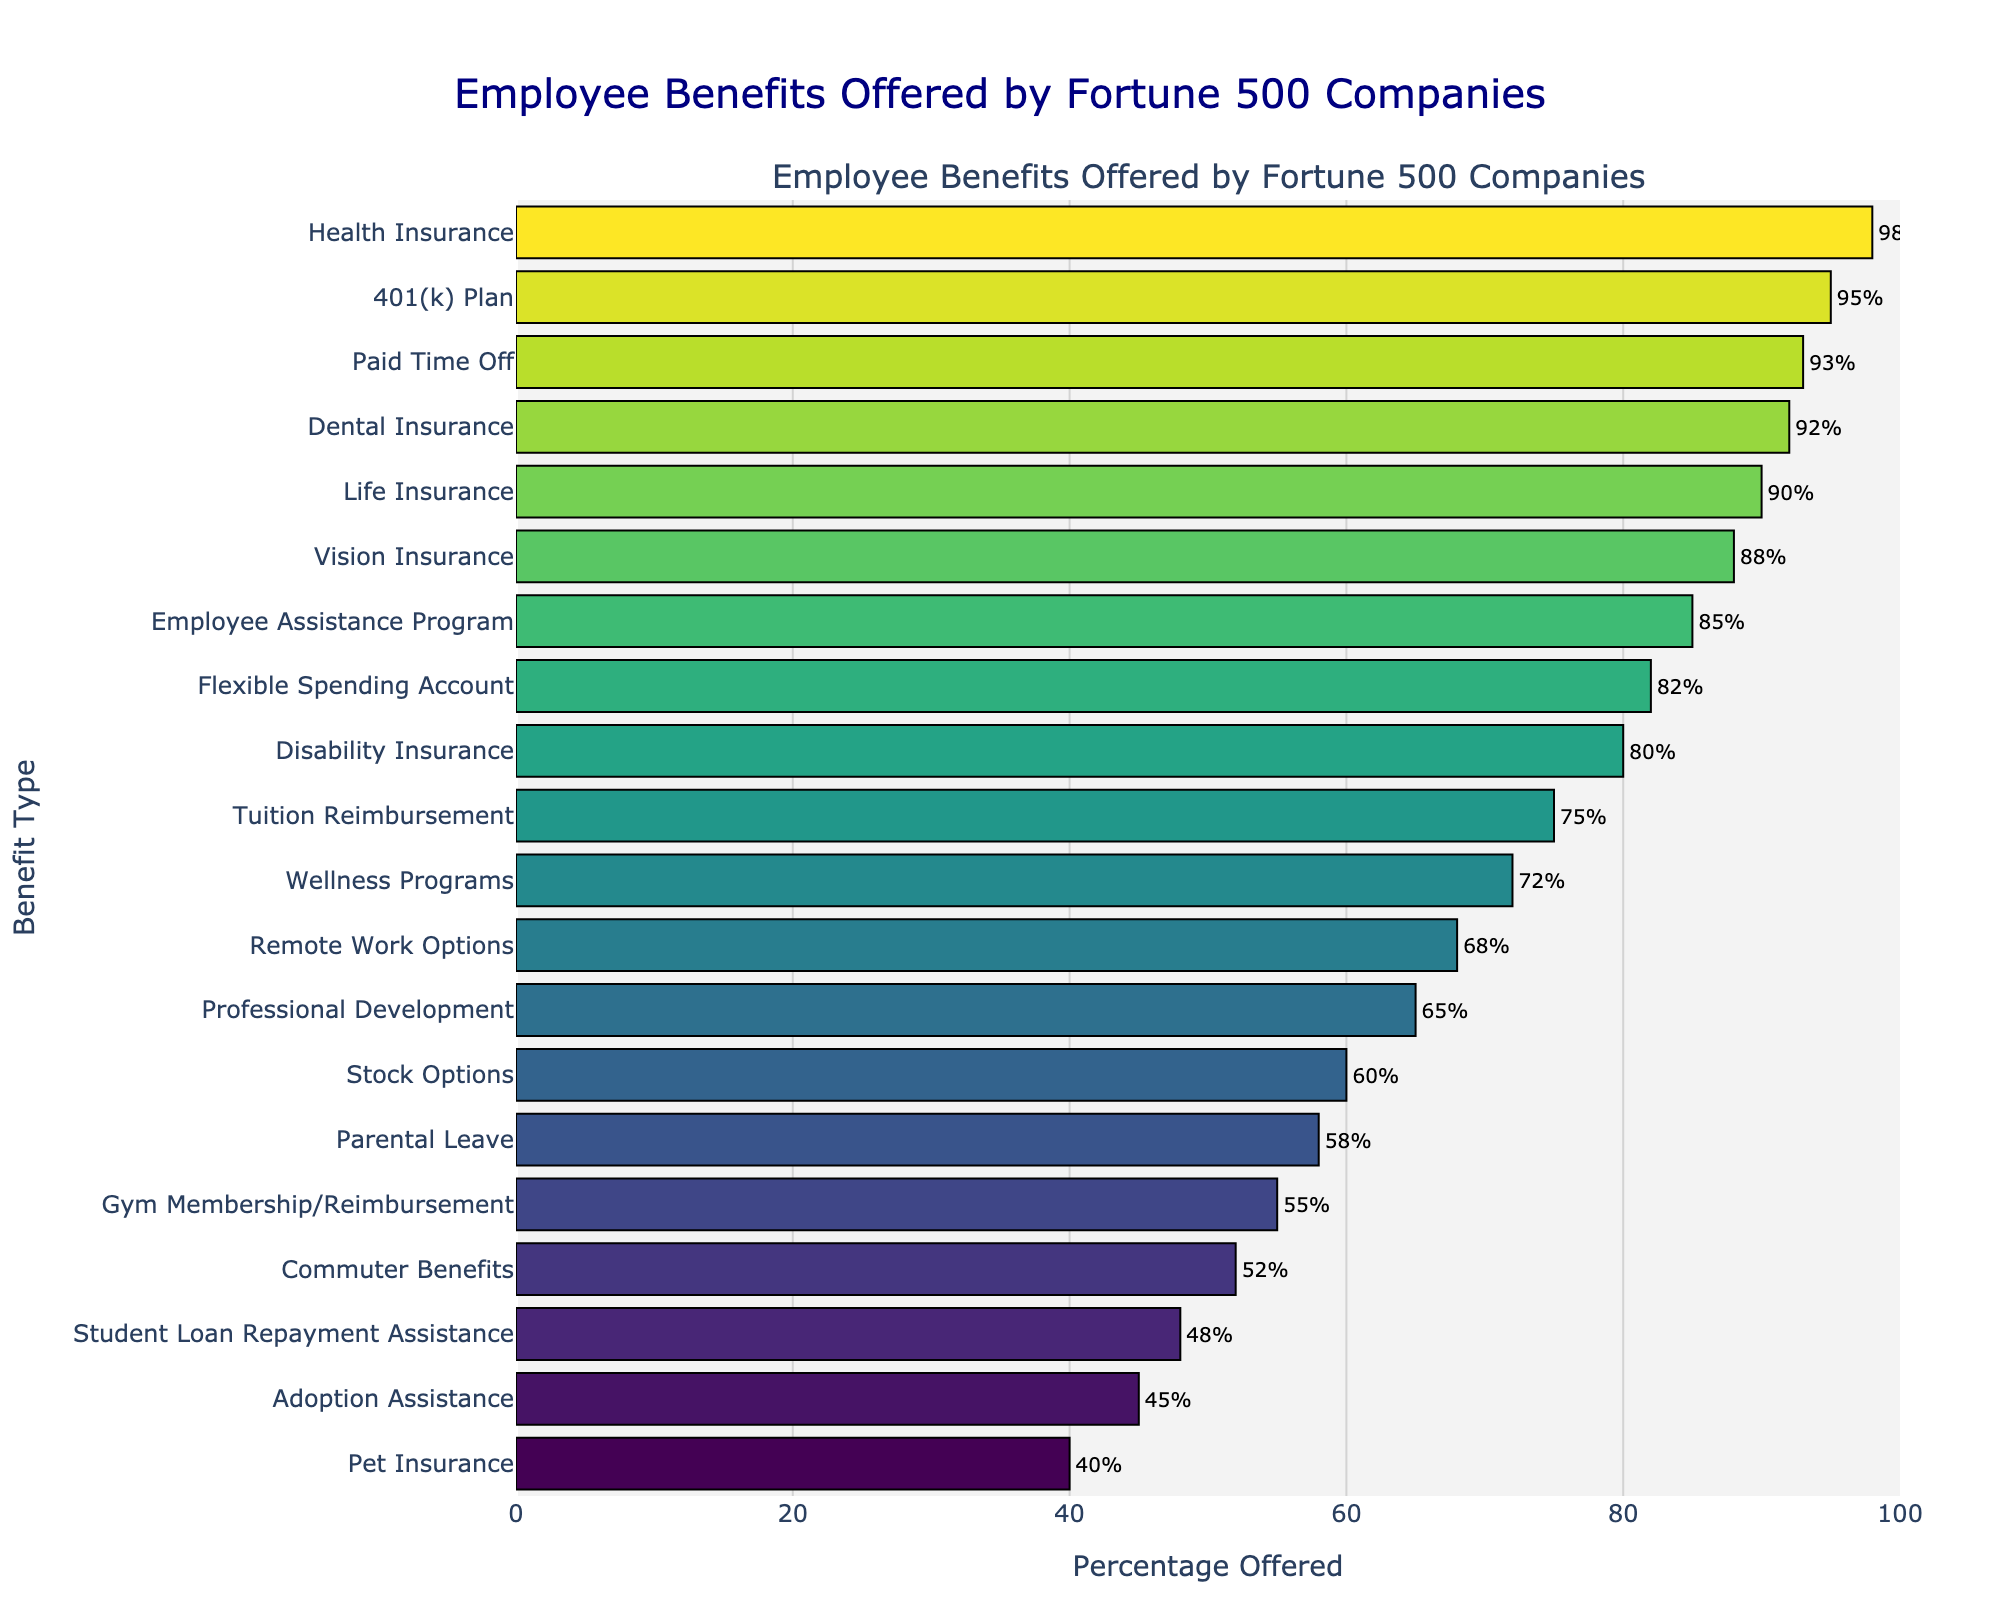What is the most commonly offered benefit among Fortune 500 companies for new hires? The most commonly offered benefit is the one with the highest percentage shown in the bar chart. Based on the chart, Health Insurance has the highest percentage at 98%.
Answer: Health Insurance Which benefit has a higher offering rate, Tuition Reimbursement or Professional Development? According to the chart, Tuition Reimbursement has a percentage of 75%, while Professional Development has a percentage of 65%. Therefore, Tuition Reimbursement has a higher offering rate.
Answer: Tuition Reimbursement How much higher is the percentage of companies offering Flexible Spending Account compared to Paid Time Off? Refer to the bar lengths for Flexible Spending Account (82%) and Paid Time Off (93%). Subtract the Flexible Spending Account percentage from the Paid Time Off percentage: 93% - 82% = 11%.
Answer: 11% What are the three least commonly offered benefits? By looking at the three shortest bars in the chart, the least commonly offered benefits are Pet Insurance (40%), Adoption Assistance (45%), and Student Loan Repayment Assistance (48%).
Answer: Pet Insurance, Adoption Assistance, Student Loan Repayment Assistance Compare the offering rates of Life Insurance and Vision Insurance. Are they equal? Life Insurance is offered at 90%, and Vision Insurance is offered at 88%. Therefore, they are not equal; Life Insurance is offered at a higher rate.
Answer: No What is the average offering percentage of these five benefits: Health Insurance, 401(k) Plan, Paid Time Off, Dental Insurance, and Life Insurance? Add the percentages of these benefits and divide by the number of benefits: (98 + 95 + 93 + 92 + 90) / 5 = 93.6%.
Answer: 93.6% Which benefit has a longer bar: Employee Assistance Program or Remote Work Options? By comparing the two bars visually, Employee Assistance Program (85%) has a longer bar than Remote Work Options (68%).
Answer: Employee Assistance Program Is the percentage of companies offering Gym Membership/Reimbursement higher or lower than that of companies offering Commuter Benefits? Gym Membership/Reimbursement is offered at 55%, whereas Commuter Benefits is offered at 52%, making the offering rate higher for Gym Membership/Reimbursement.
Answer: Higher What is the total percentage of companies offering both Disability Insurance and Adoption Assistance? Disability Insurance is offered at 80%, and Adoption Assistance is offered at 45%. Summing these percentages gives 80% + 45% = 125%.
Answer: 125% 